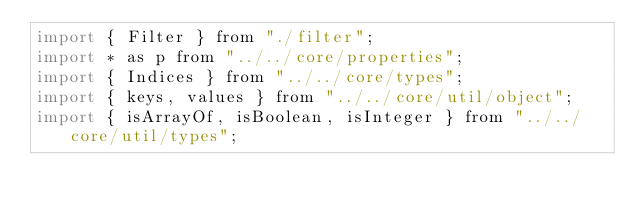<code> <loc_0><loc_0><loc_500><loc_500><_JavaScript_>import { Filter } from "./filter";
import * as p from "../../core/properties";
import { Indices } from "../../core/types";
import { keys, values } from "../../core/util/object";
import { isArrayOf, isBoolean, isInteger } from "../../core/util/types";</code> 